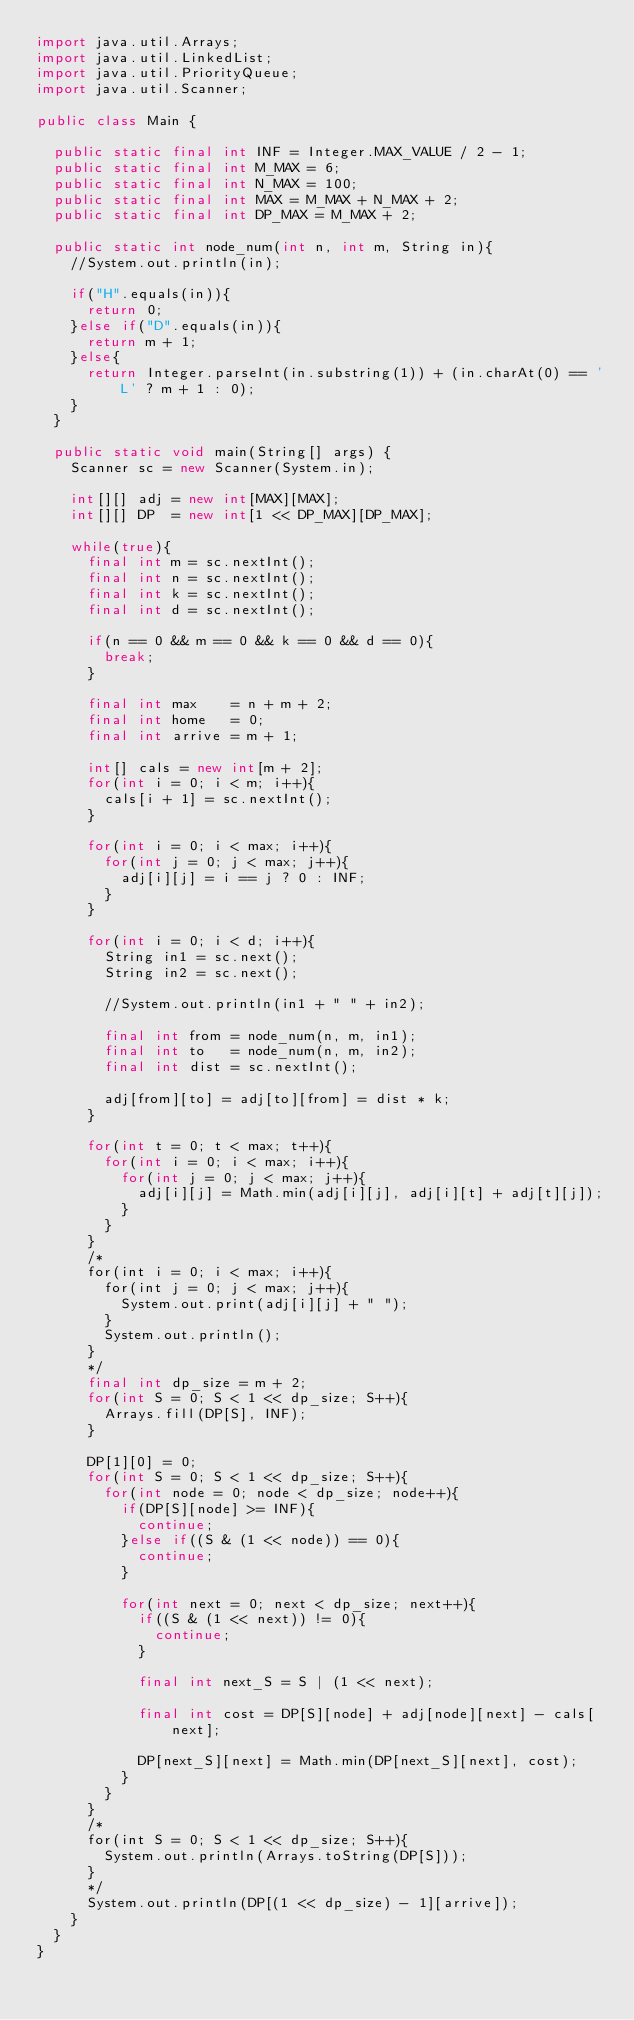<code> <loc_0><loc_0><loc_500><loc_500><_Java_>import java.util.Arrays;
import java.util.LinkedList;
import java.util.PriorityQueue;
import java.util.Scanner;

public class Main {
	
	public static final int INF = Integer.MAX_VALUE / 2 - 1;
	public static final int M_MAX = 6;
	public static final int N_MAX = 100;
	public static final int MAX = M_MAX + N_MAX + 2;
	public static final int DP_MAX = M_MAX + 2;
	
	public static int node_num(int n, int m, String in){
		//System.out.println(in);
		
		if("H".equals(in)){
			return 0;
		}else if("D".equals(in)){
			return m + 1;
		}else{
			return Integer.parseInt(in.substring(1)) + (in.charAt(0) == 'L' ? m + 1 : 0);
		}
	}
	
	public static void main(String[] args) {
		Scanner sc = new Scanner(System.in);
		
		int[][] adj = new int[MAX][MAX];
		int[][] DP  = new int[1 << DP_MAX][DP_MAX];
		
		while(true){
			final int m = sc.nextInt();
			final int n = sc.nextInt();
			final int k = sc.nextInt();
			final int d = sc.nextInt();
			
			if(n == 0 && m == 0 && k == 0 && d == 0){
				break;
			}
			
			final int max    = n + m + 2; 
			final int home   = 0;
			final int arrive = m + 1;
			
			int[] cals = new int[m + 2];
			for(int i = 0; i < m; i++){
				cals[i + 1] = sc.nextInt();
			}
			
			for(int i = 0; i < max; i++){
				for(int j = 0; j < max; j++){
					adj[i][j] = i == j ? 0 : INF;
				}
			}
			
			for(int i = 0; i < d; i++){
				String in1 = sc.next();
				String in2 = sc.next();
				
				//System.out.println(in1 + " " + in2);
				
				final int from = node_num(n, m, in1);
				final int to   = node_num(n, m, in2);
				final int dist = sc.nextInt();
				
				adj[from][to] = adj[to][from] = dist * k;
			}
			
			for(int t = 0; t < max; t++){
				for(int i = 0; i < max; i++){
					for(int j = 0; j < max; j++){
						adj[i][j] = Math.min(adj[i][j], adj[i][t] + adj[t][j]);
					}
				}
			}
			/*
			for(int i = 0; i < max; i++){
				for(int j = 0; j < max; j++){
					System.out.print(adj[i][j] + " ");
				}
				System.out.println();
			}
			*/
			final int dp_size = m + 2;
			for(int S = 0; S < 1 << dp_size; S++){
				Arrays.fill(DP[S], INF);
			}
			
			DP[1][0] = 0;
			for(int S = 0; S < 1 << dp_size; S++){
				for(int node = 0; node < dp_size; node++){
					if(DP[S][node] >= INF){
						continue;
					}else if((S & (1 << node)) == 0){
						continue;
					}
					
					for(int next = 0; next < dp_size; next++){
						if((S & (1 << next)) != 0){
							continue;
						}
						
						final int next_S = S | (1 << next);
						
						final int cost = DP[S][node] + adj[node][next] - cals[next];
						
						DP[next_S][next] = Math.min(DP[next_S][next], cost);
					}
				}
			}
			/*
			for(int S = 0; S < 1 << dp_size; S++){
				System.out.println(Arrays.toString(DP[S]));
			}
			*/
			System.out.println(DP[(1 << dp_size) - 1][arrive]);
		}
	}
}</code> 